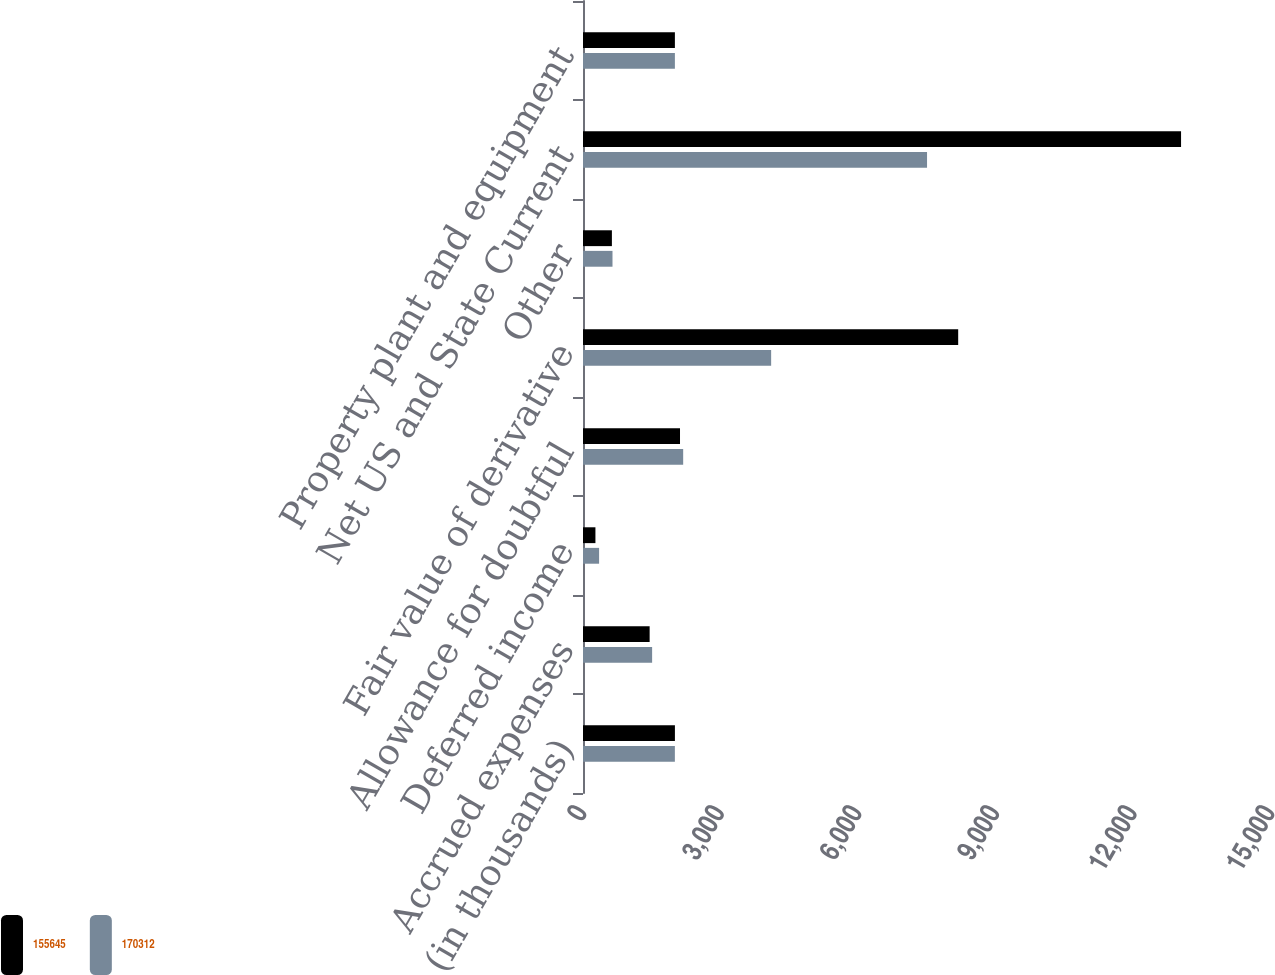<chart> <loc_0><loc_0><loc_500><loc_500><stacked_bar_chart><ecel><fcel>(in thousands)<fcel>Accrued expenses<fcel>Deferred income<fcel>Allowance for doubtful<fcel>Fair value of derivative<fcel>Other<fcel>Net US and State Current<fcel>Property plant and equipment<nl><fcel>155645<fcel>2004<fcel>1453<fcel>271<fcel>2115<fcel>8180<fcel>630<fcel>13039<fcel>2003.5<nl><fcel>170312<fcel>2003<fcel>1507<fcel>351<fcel>2184<fcel>4102<fcel>643<fcel>7501<fcel>2003.5<nl></chart> 